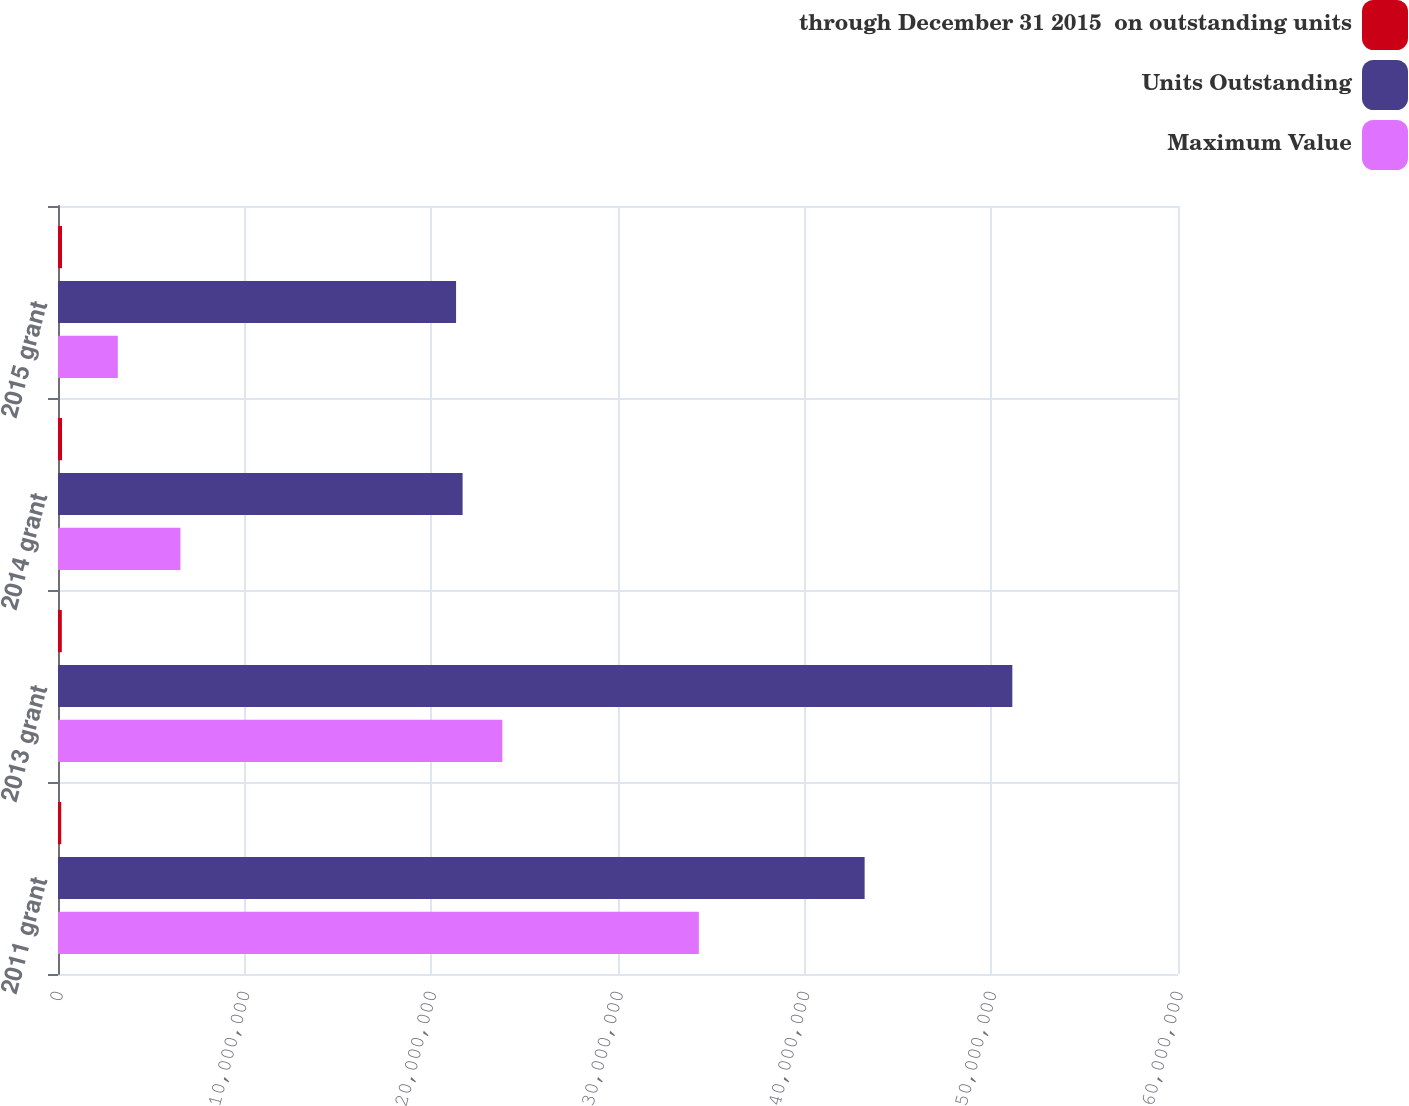Convert chart. <chart><loc_0><loc_0><loc_500><loc_500><stacked_bar_chart><ecel><fcel>2011 grant<fcel>2013 grant<fcel>2014 grant<fcel>2015 grant<nl><fcel>through December 31 2015  on outstanding units<fcel>172850<fcel>204500<fcel>216750<fcel>213250<nl><fcel>Units Outstanding<fcel>4.32125e+07<fcel>5.1125e+07<fcel>2.1675e+07<fcel>2.1325e+07<nl><fcel>Maximum Value<fcel>3.4331e+07<fcel>2.3804e+07<fcel>6.559e+06<fcel>3.205e+06<nl></chart> 